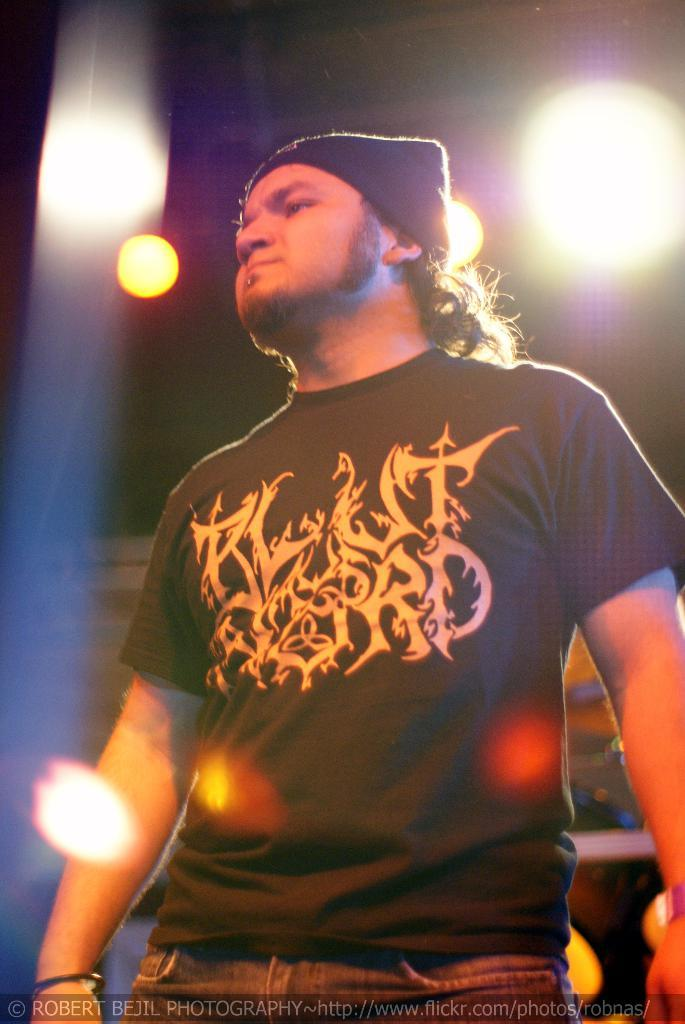What is the main subject in the foreground of the image? There is a man in the foreground of the image. What is the man doing in the image? The man is standing in the image. What type of clothing is the man wearing on his head? The man is wearing a cap in the image. What can be seen in the background of the image? There are lights visible in the background of the image. What type of stocking is the man wearing in the image? There is no mention of stockings in the image, so it cannot be determined if the man is wearing any. 